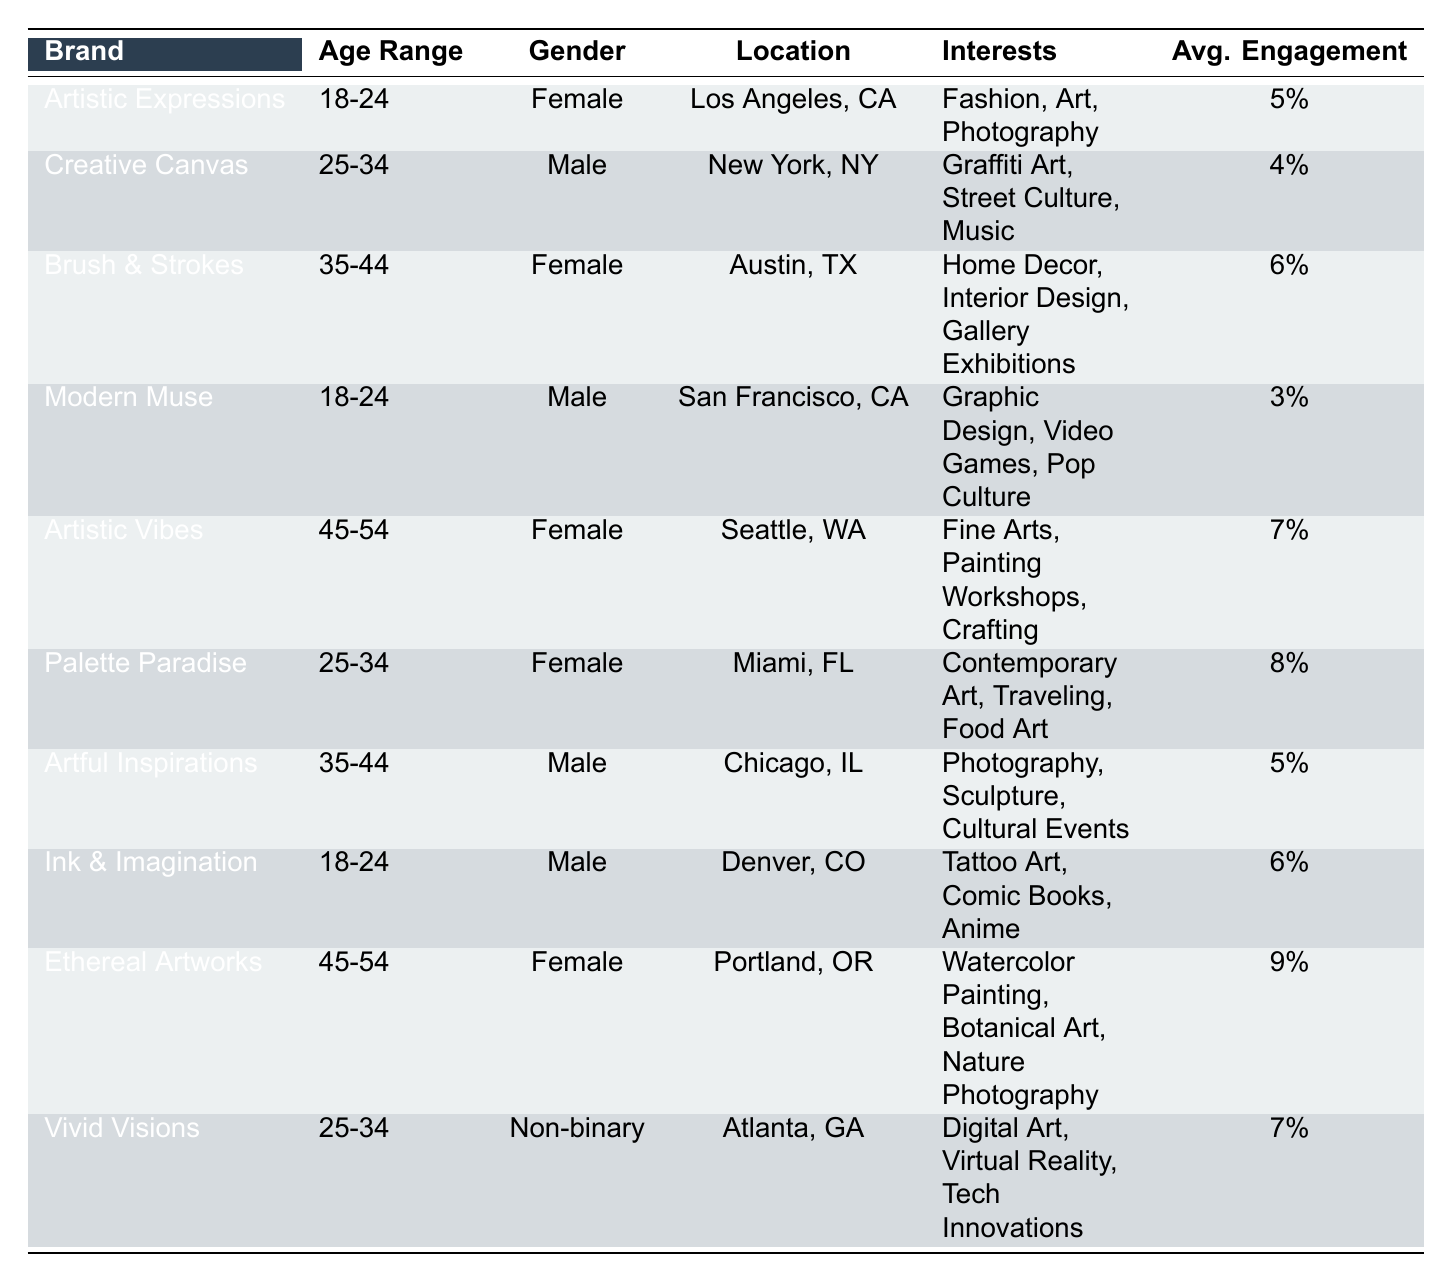What is the average engagement rate for the brand "Palette Paradise"? The engagement rate for "Palette Paradise" is listed in the table as 8%. Therefore, the average engagement rate for this brand is 8%.
Answer: 8% Which brand has the highest average engagement rate? By scanning through the average engagement rates listed in the table, "Ethereal Artworks" has the highest average engagement rate at 9%.
Answer: Ethereal Artworks Are there more male or female followers across all brands? From the table, we count the genders: Male (4) and Female (5). Since the number of female followers is greater than male followers, the answer is yes, there are more female followers.
Answer: Yes What is the age range of followers for the brand "Artistic Vibes"? Referring to the table, "Artistic Vibes" is associated with the age range 45-54. Therefore, the age range of followers is 45-54.
Answer: 45-54 Which brand is located in Seattle, WA, and what are its interests? The brand located in Seattle, WA is "Artistic Vibes" and its interests listed in the table include Fine Arts, Painting Workshops, and Crafting.
Answer: Artistic Vibes; Fine Arts, Painting Workshops, Crafting How many brands target audiences aged 35-44? Scanning the table reveals that there are 3 brands targeting the audience aged 35-44, specifically "Brush & Strokes," "Artful Inspirations," and "Palette Paradise."
Answer: 3 Is there a brand targeting non-binary followers? The table shows "Vivid Visions" which specifically targets non-binary followers, indicated under the gender column. Hence, the answer is yes.
Answer: Yes What is the average engagement rate of brands targeting the age range 25-34? The brands targeting age range 25-34 are "Creative Canvas," "Palette Paradise," and "Vivid Visions" with engagement rates of 4%, 8%, and 7% respectively. To find the average, we sum 4 + 8 + 7 = 19, then divide by 3, resulting in an average of 6.33%.
Answer: 6.33% Which location has the highest number of brands? The locations represented in the table are Los Angeles, New York, Austin, San Francisco, Seattle, Miami, Chicago, Denver, and Portland. Each appears once except for "Los Angeles" where returns one brand, as does "Chicago," hence there are no duplicates. Therefore, all locations are tied with one brand each.
Answer: None, all locations are unique 